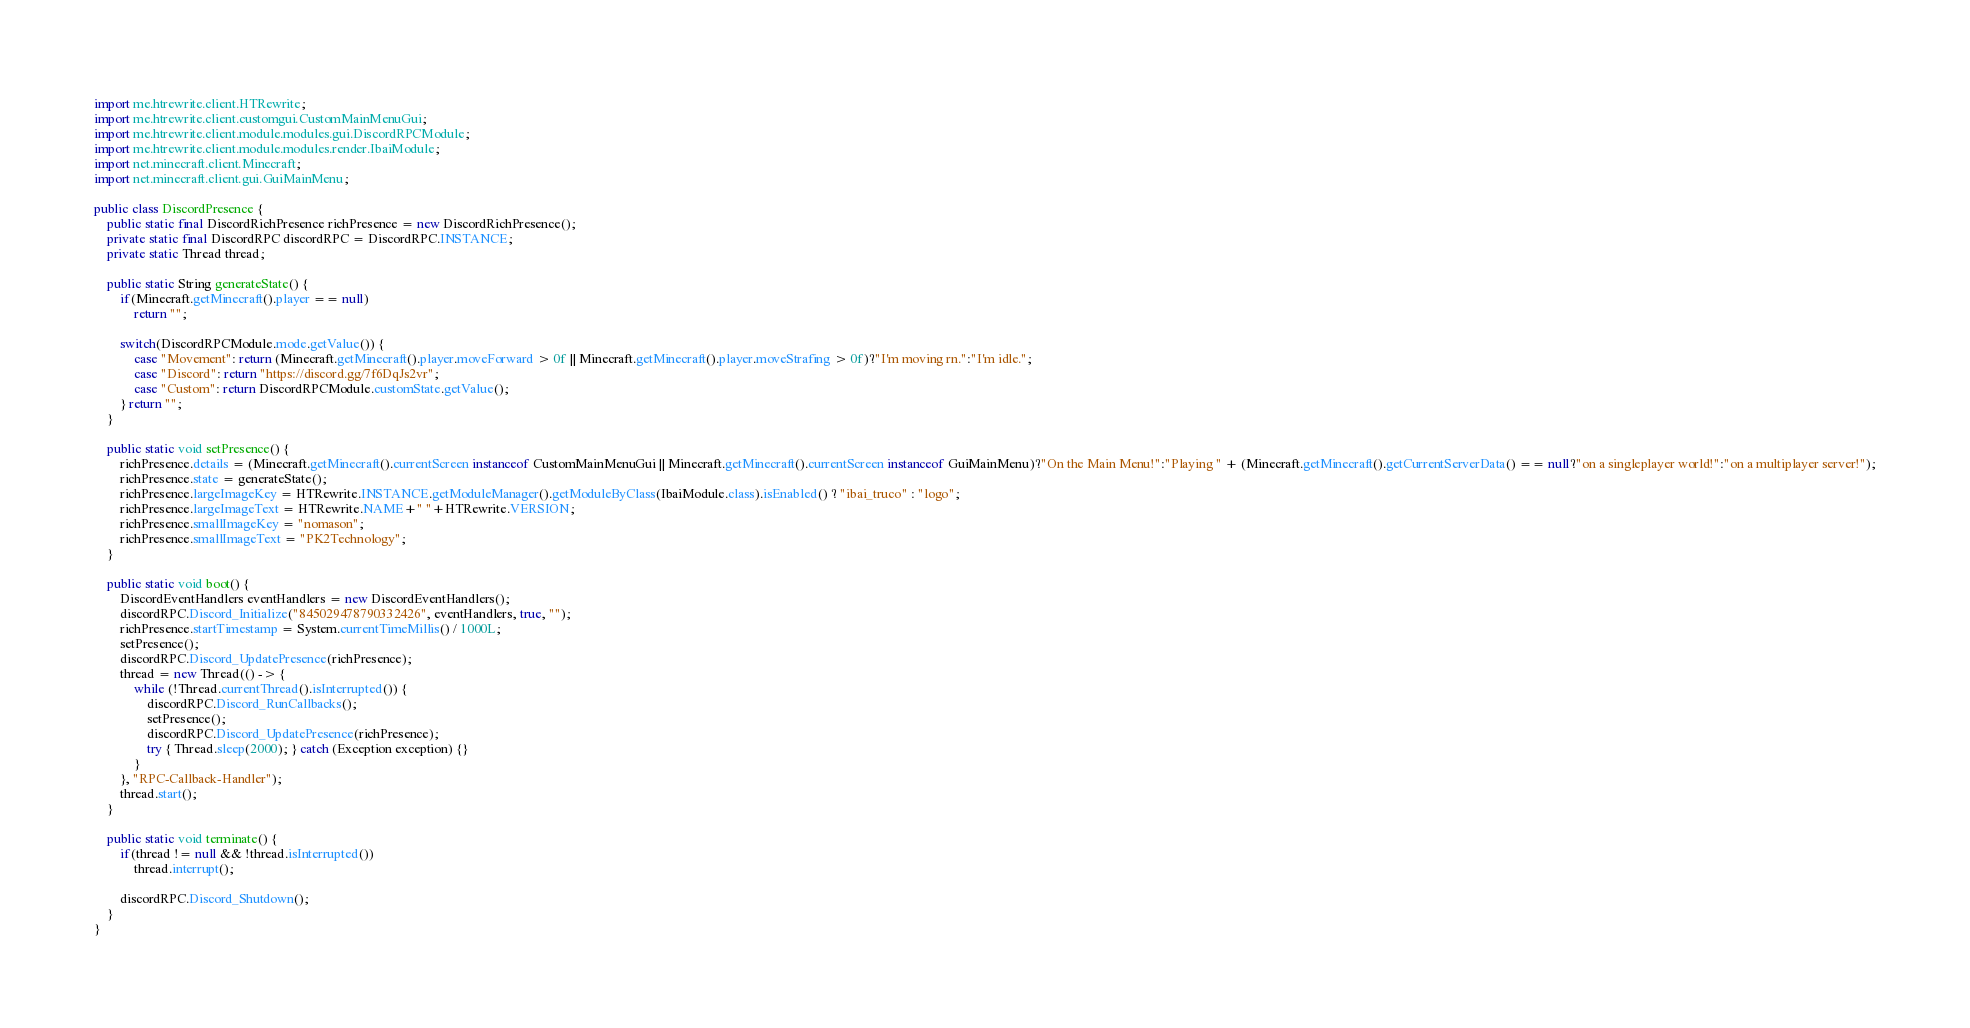<code> <loc_0><loc_0><loc_500><loc_500><_Java_>import me.htrewrite.client.HTRewrite;
import me.htrewrite.client.customgui.CustomMainMenuGui;
import me.htrewrite.client.module.modules.gui.DiscordRPCModule;
import me.htrewrite.client.module.modules.render.IbaiModule;
import net.minecraft.client.Minecraft;
import net.minecraft.client.gui.GuiMainMenu;

public class DiscordPresence {
    public static final DiscordRichPresence richPresence = new DiscordRichPresence();
    private static final DiscordRPC discordRPC = DiscordRPC.INSTANCE;
    private static Thread thread;

    public static String generateState() {
        if(Minecraft.getMinecraft().player == null)
            return "";

        switch(DiscordRPCModule.mode.getValue()) {
            case "Movement": return (Minecraft.getMinecraft().player.moveForward > 0f || Minecraft.getMinecraft().player.moveStrafing > 0f)?"I'm moving rn.":"I'm idle.";
            case "Discord": return "https://discord.gg/7f6DqJs2vr";
            case "Custom": return DiscordRPCModule.customState.getValue();
        } return "";
    }

    public static void setPresence() {
        richPresence.details = (Minecraft.getMinecraft().currentScreen instanceof CustomMainMenuGui || Minecraft.getMinecraft().currentScreen instanceof GuiMainMenu)?"On the Main Menu!":"Playing " + (Minecraft.getMinecraft().getCurrentServerData() == null?"on a singleplayer world!":"on a multiplayer server!");
        richPresence.state = generateState();
        richPresence.largeImageKey = HTRewrite.INSTANCE.getModuleManager().getModuleByClass(IbaiModule.class).isEnabled() ? "ibai_truco" : "logo";
        richPresence.largeImageText = HTRewrite.NAME+" "+HTRewrite.VERSION;
        richPresence.smallImageKey = "nomason";
        richPresence.smallImageText = "PK2Technology";
    }

    public static void boot() {
        DiscordEventHandlers eventHandlers = new DiscordEventHandlers();
        discordRPC.Discord_Initialize("845029478790332426", eventHandlers, true, "");
        richPresence.startTimestamp = System.currentTimeMillis() / 1000L;
        setPresence();
        discordRPC.Discord_UpdatePresence(richPresence);
        thread = new Thread(() -> {
            while (!Thread.currentThread().isInterrupted()) {
                discordRPC.Discord_RunCallbacks();
                setPresence();
                discordRPC.Discord_UpdatePresence(richPresence);
                try { Thread.sleep(2000); } catch (Exception exception) {}
            }
        }, "RPC-Callback-Handler");
        thread.start();
    }

    public static void terminate() {
        if(thread != null && !thread.isInterrupted())
            thread.interrupt();

        discordRPC.Discord_Shutdown();
    }
}</code> 